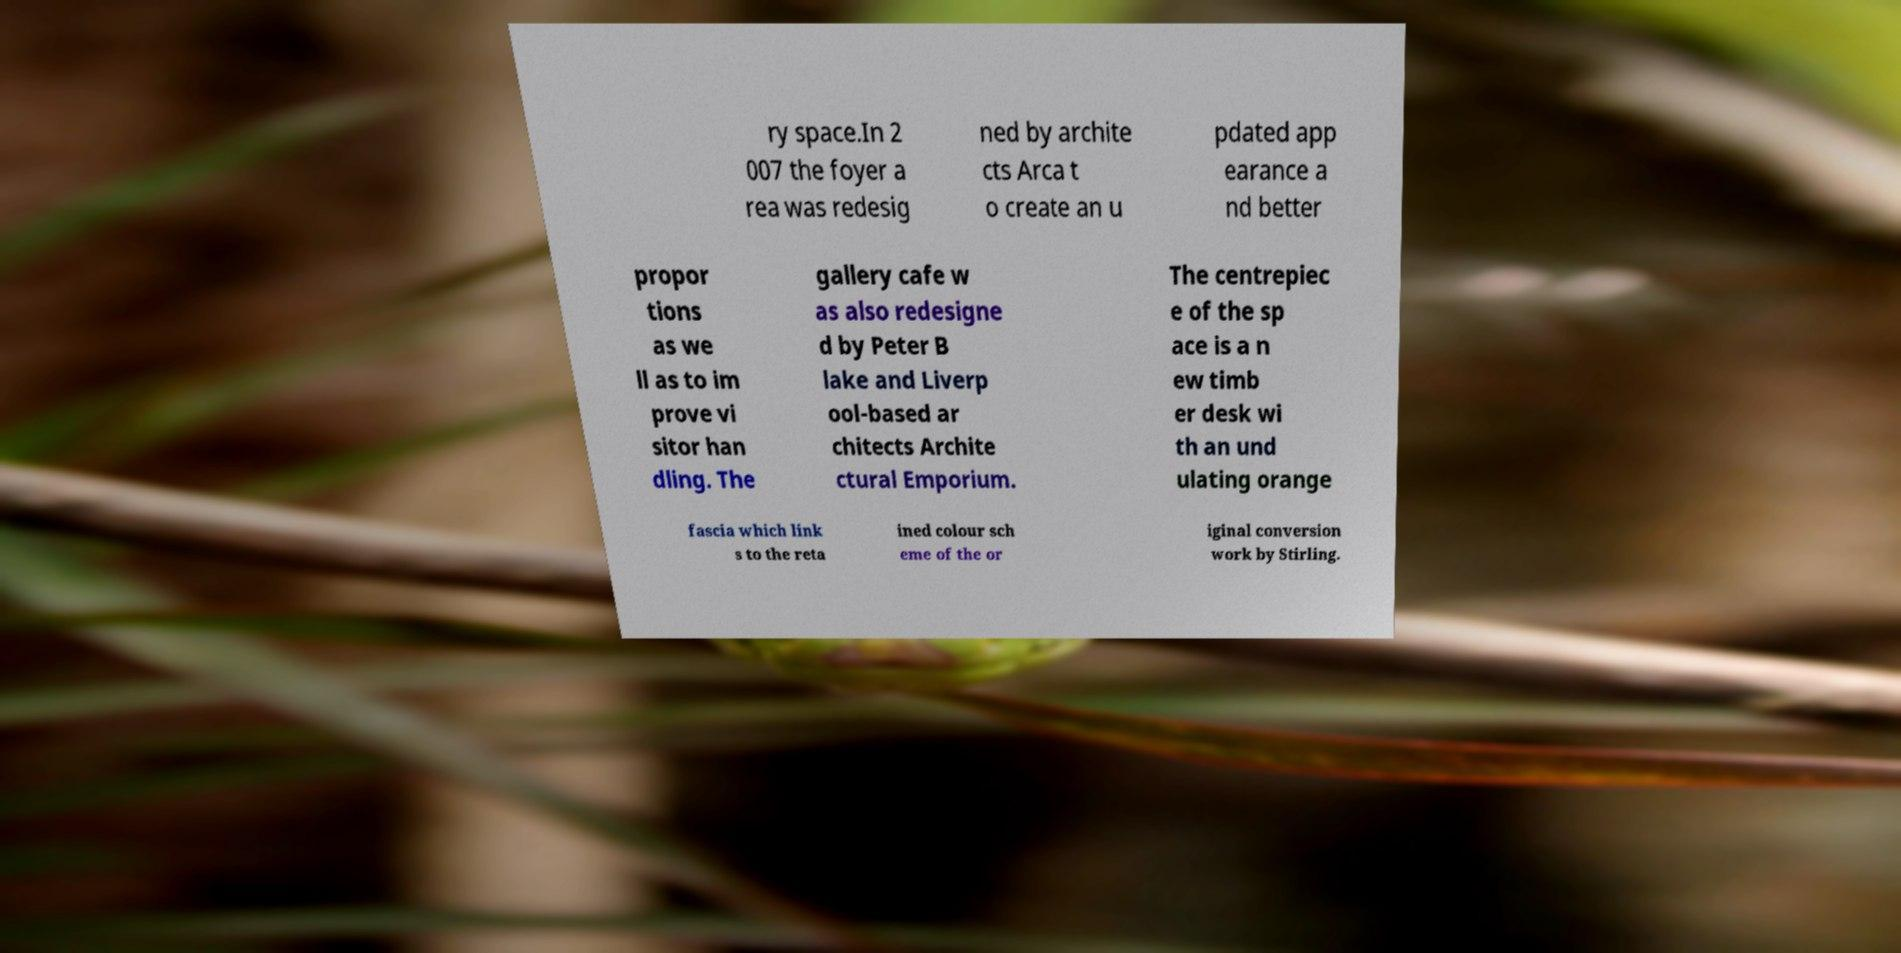For documentation purposes, I need the text within this image transcribed. Could you provide that? ry space.In 2 007 the foyer a rea was redesig ned by archite cts Arca t o create an u pdated app earance a nd better propor tions as we ll as to im prove vi sitor han dling. The gallery cafe w as also redesigne d by Peter B lake and Liverp ool-based ar chitects Archite ctural Emporium. The centrepiec e of the sp ace is a n ew timb er desk wi th an und ulating orange fascia which link s to the reta ined colour sch eme of the or iginal conversion work by Stirling. 